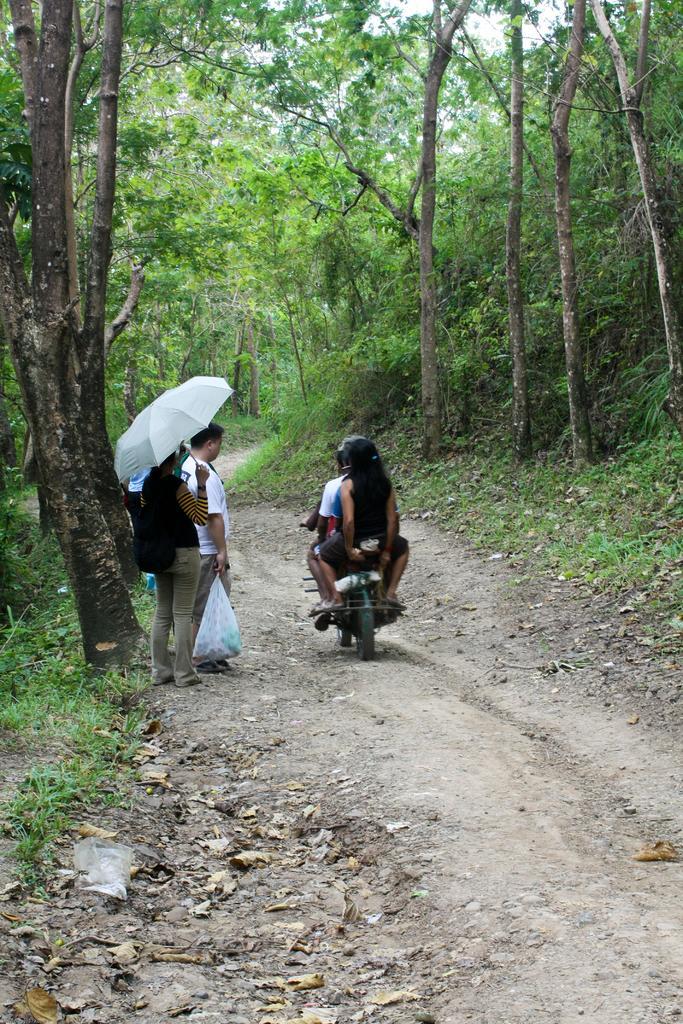Can you describe this image briefly? This picture is clicked outside. In the center we can see there are some persons sitting on the bike and the bike is running on the ground. On the left we can see a person wearing a backpack, holding a white color umbrella and standing on the ground and there is another person holding a bag and standing on the ground. In the foreground we can see the dry leaves. In the background there is a sky, trees, plants and the green grass. 